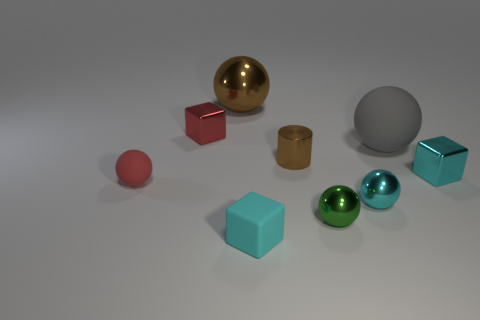How big is the red thing behind the cyan metallic object that is on the right side of the gray thing?
Your answer should be very brief. Small. Does the tiny red thing behind the tiny red sphere have the same material as the red sphere?
Provide a succinct answer. No. There is a shiny object on the left side of the brown ball; what is its shape?
Offer a very short reply. Cube. What number of metallic cubes have the same size as the cyan sphere?
Ensure brevity in your answer.  2. The red sphere is what size?
Provide a succinct answer. Small. There is a cylinder; how many large balls are on the left side of it?
Make the answer very short. 1. What is the shape of the big brown thing that is the same material as the small red block?
Offer a very short reply. Sphere. Is the number of small metal cubes behind the big gray object less than the number of cyan cubes to the right of the green thing?
Keep it short and to the point. No. Are there more big brown metal spheres than green shiny cylinders?
Provide a short and direct response. Yes. What is the small brown thing made of?
Provide a short and direct response. Metal. 